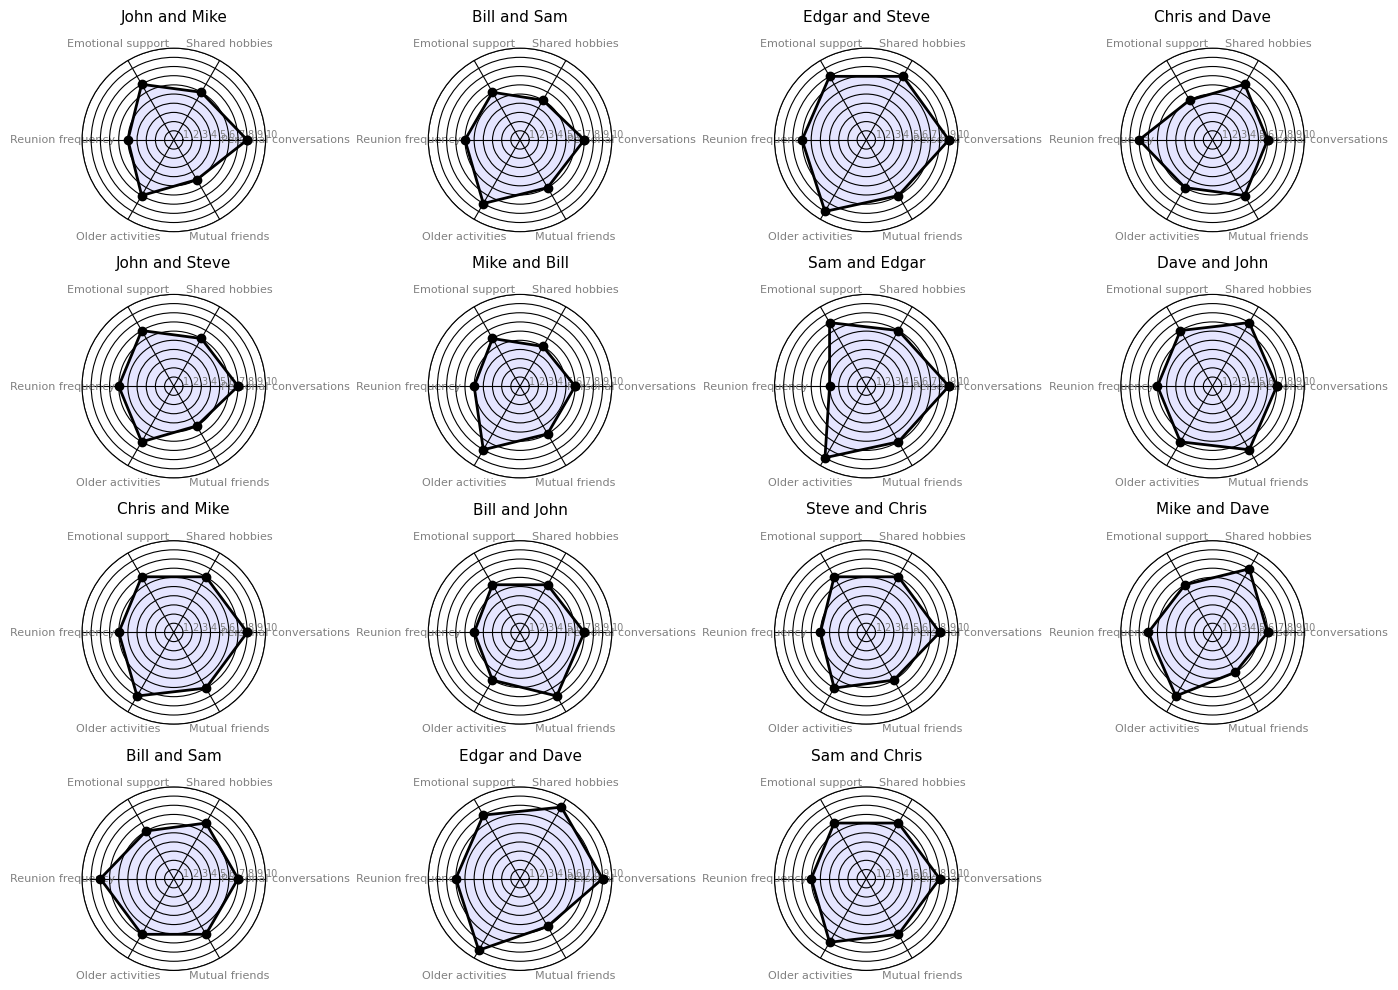Which pair has the highest value for "Personal conversations"? Look at the "Personal conversations" values for each pair; the maximum value is 9, which is shared between Edgar and Steve, and Sam and Edgar.
Answer: Edgar and Steve, Sam and Edgar Which category differs the most between "John and Mike" and "Bill and Sam"? By examining the charts for "John and Mike" and "Bill and Sam," we compare each category and find that "Reunion frequency" has the largest difference (5 vs. 6).
Answer: Reunion frequency What is the average "Emotional support" value across all pairs? Add up the "Emotional support" values for all pairs (7+6+8+5+7+6+8+7+7+6+7+6+6+8+7) and divide by the number of pairs (15). The total is 101, and the average is 101/15 ≈ 6.73.
Answer: ~6.73 Who has the most balanced friendship network across the six categories? Balance means the least variation in values. Compare the plots visually and check each category for each pair. “Chris and Dave” has most values closer to each other (6,7,5,8,6,7).
Answer: Chris and Dave Between "Edgar and Steve" and "Edgar and Dave", which pair participates more in older activities and by how much? Check "Older activities" for both pairs; Edgar and Steve have 9, and Edgar and Dave also have 9. The difference is 0.
Answer: They are equal Which pair exhibits the greatest diversity in the mutual friends category? Look at the range of values for "Mutual friends" on each chart; compare the highest and lowest values per pair. The pair with the value of 8 (maximum) is "Bill and John" and the lowest value, 5, appears for multiple pairs. The range for other pairs is mostly 2 or 1. Therefore "Bill and John" has a diversity of 2.
Answer: Bill and John How often do "Chris and Mike" reunite compared to "Chris and Dave"? Examine "Reunion frequency" for both pairs; it's 6 for Chris and Mike, and 8 for Chris and Dave. Chris and Dave reunites more often by 2 units.
Answer: Chris and Dave by 2 What is the combined score for "John and Steve" in all categories? Sum the values for "John and Steve" across all categories: 7+6+7+6+7+5 = 38.
Answer: 38 Which pair shows similar support levels in both "Personal conversations" and "Emotional support"? Compare values of "Personal conversations" and "Emotional support" per pair; "John and Mike" has values 8 and 7 which are close.
Answer: John and Mike Comparing "Shared hobbies" between all pairs, which pair stands out and why? Look at the radar chart, observing "Shared hobbies"; "Edgar and Dave" stands out with the highest value of 9.
Answer: Edgar and Dave 